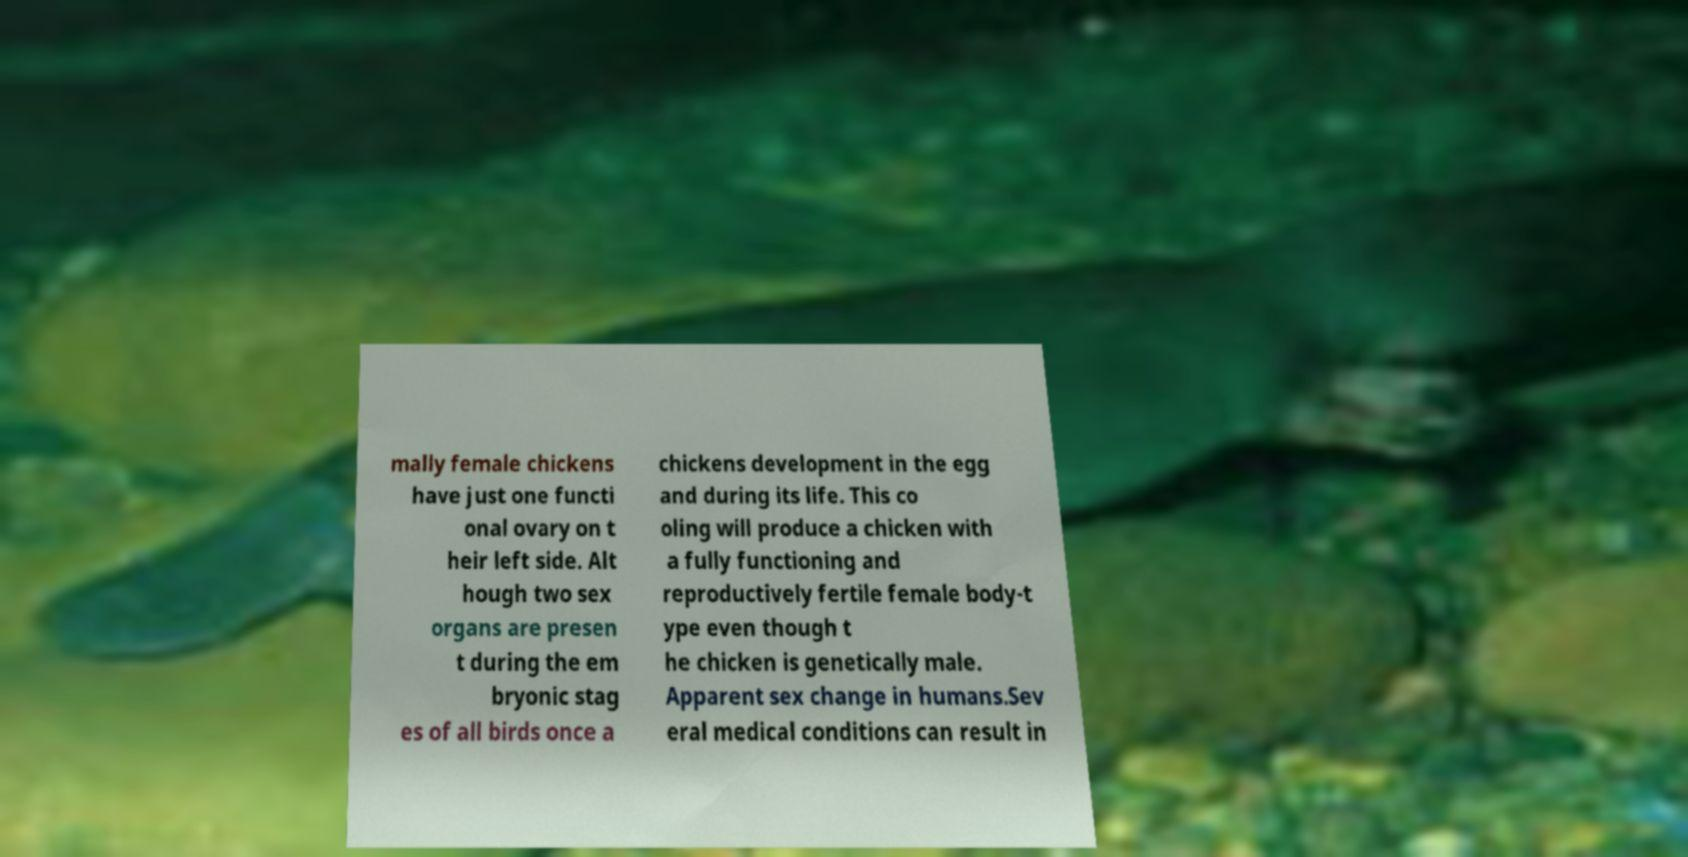Please identify and transcribe the text found in this image. mally female chickens have just one functi onal ovary on t heir left side. Alt hough two sex organs are presen t during the em bryonic stag es of all birds once a chickens development in the egg and during its life. This co oling will produce a chicken with a fully functioning and reproductively fertile female body-t ype even though t he chicken is genetically male. Apparent sex change in humans.Sev eral medical conditions can result in 